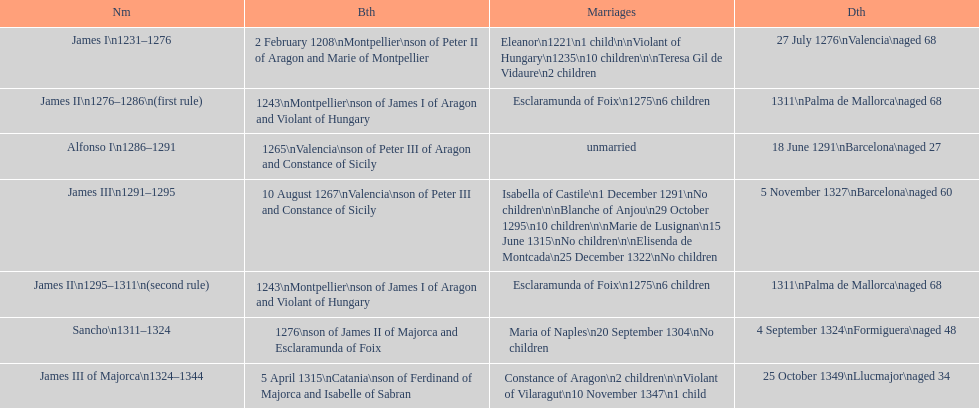How many total marriages did james i have? 3. 